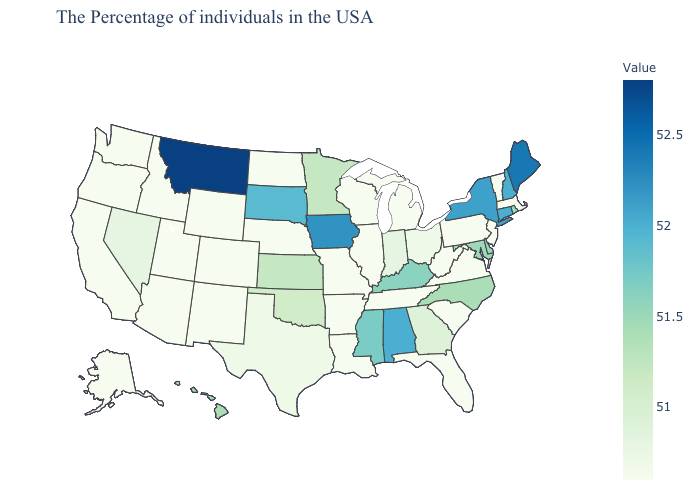Does Delaware have the lowest value in the South?
Write a very short answer. No. Does Delaware have a lower value than Alabama?
Keep it brief. Yes. Among the states that border Minnesota , does Iowa have the highest value?
Give a very brief answer. Yes. Among the states that border Oklahoma , does Kansas have the highest value?
Keep it brief. Yes. Which states have the highest value in the USA?
Be succinct. Montana. Which states hav the highest value in the West?
Concise answer only. Montana. 